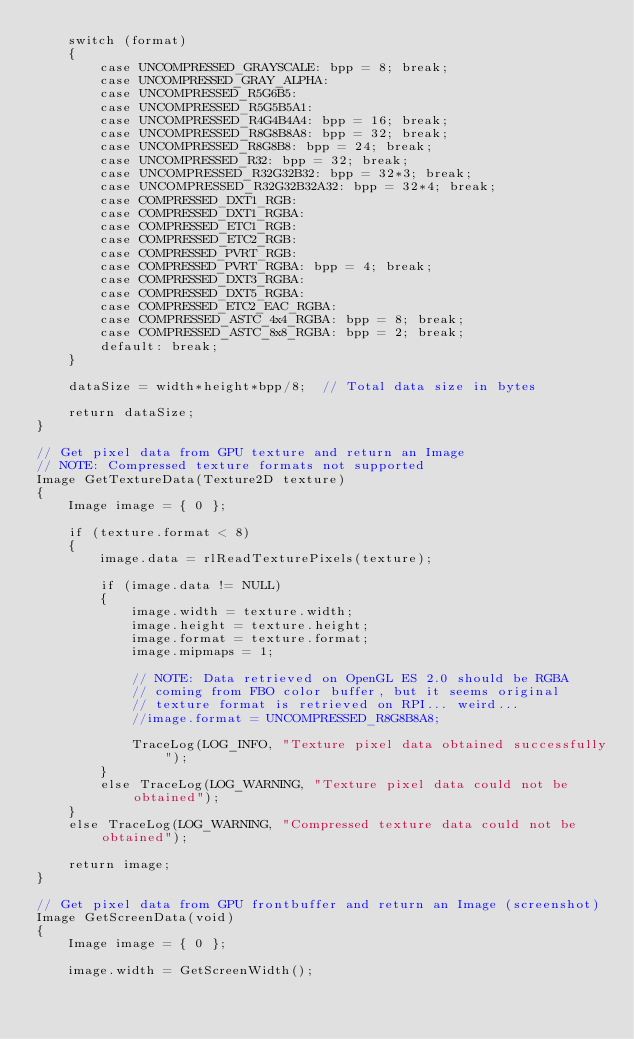Convert code to text. <code><loc_0><loc_0><loc_500><loc_500><_C_>    switch (format)
    {
        case UNCOMPRESSED_GRAYSCALE: bpp = 8; break;
        case UNCOMPRESSED_GRAY_ALPHA:
        case UNCOMPRESSED_R5G6B5:
        case UNCOMPRESSED_R5G5B5A1:
        case UNCOMPRESSED_R4G4B4A4: bpp = 16; break;
        case UNCOMPRESSED_R8G8B8A8: bpp = 32; break;
        case UNCOMPRESSED_R8G8B8: bpp = 24; break;
        case UNCOMPRESSED_R32: bpp = 32; break;
        case UNCOMPRESSED_R32G32B32: bpp = 32*3; break;
        case UNCOMPRESSED_R32G32B32A32: bpp = 32*4; break;
        case COMPRESSED_DXT1_RGB:
        case COMPRESSED_DXT1_RGBA:
        case COMPRESSED_ETC1_RGB:
        case COMPRESSED_ETC2_RGB:
        case COMPRESSED_PVRT_RGB:
        case COMPRESSED_PVRT_RGBA: bpp = 4; break;
        case COMPRESSED_DXT3_RGBA:
        case COMPRESSED_DXT5_RGBA:
        case COMPRESSED_ETC2_EAC_RGBA:
        case COMPRESSED_ASTC_4x4_RGBA: bpp = 8; break;
        case COMPRESSED_ASTC_8x8_RGBA: bpp = 2; break;
        default: break;
    }

    dataSize = width*height*bpp/8;  // Total data size in bytes

    return dataSize;
}

// Get pixel data from GPU texture and return an Image
// NOTE: Compressed texture formats not supported
Image GetTextureData(Texture2D texture)
{
    Image image = { 0 };

    if (texture.format < 8)
    {
        image.data = rlReadTexturePixels(texture);

        if (image.data != NULL)
        {
            image.width = texture.width;
            image.height = texture.height;
            image.format = texture.format;
            image.mipmaps = 1;

            // NOTE: Data retrieved on OpenGL ES 2.0 should be RGBA
            // coming from FBO color buffer, but it seems original
            // texture format is retrieved on RPI... weird...
            //image.format = UNCOMPRESSED_R8G8B8A8;

            TraceLog(LOG_INFO, "Texture pixel data obtained successfully");
        }
        else TraceLog(LOG_WARNING, "Texture pixel data could not be obtained");
    }
    else TraceLog(LOG_WARNING, "Compressed texture data could not be obtained");

    return image;
}

// Get pixel data from GPU frontbuffer and return an Image (screenshot)
Image GetScreenData(void)
{
    Image image = { 0 };

    image.width = GetScreenWidth();</code> 